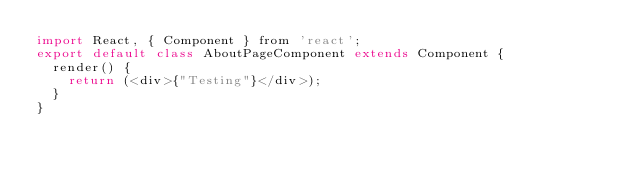<code> <loc_0><loc_0><loc_500><loc_500><_JavaScript_>import React, { Component } from 'react';
export default class AboutPageComponent extends Component {
  render() {
    return (<div>{"Testing"}</div>);
  }
}</code> 